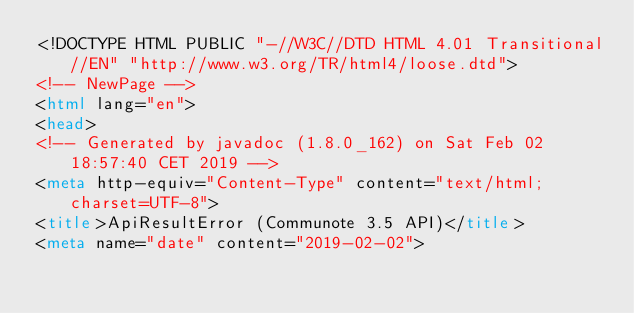<code> <loc_0><loc_0><loc_500><loc_500><_HTML_><!DOCTYPE HTML PUBLIC "-//W3C//DTD HTML 4.01 Transitional//EN" "http://www.w3.org/TR/html4/loose.dtd">
<!-- NewPage -->
<html lang="en">
<head>
<!-- Generated by javadoc (1.8.0_162) on Sat Feb 02 18:57:40 CET 2019 -->
<meta http-equiv="Content-Type" content="text/html; charset=UTF-8">
<title>ApiResultError (Communote 3.5 API)</title>
<meta name="date" content="2019-02-02"></code> 